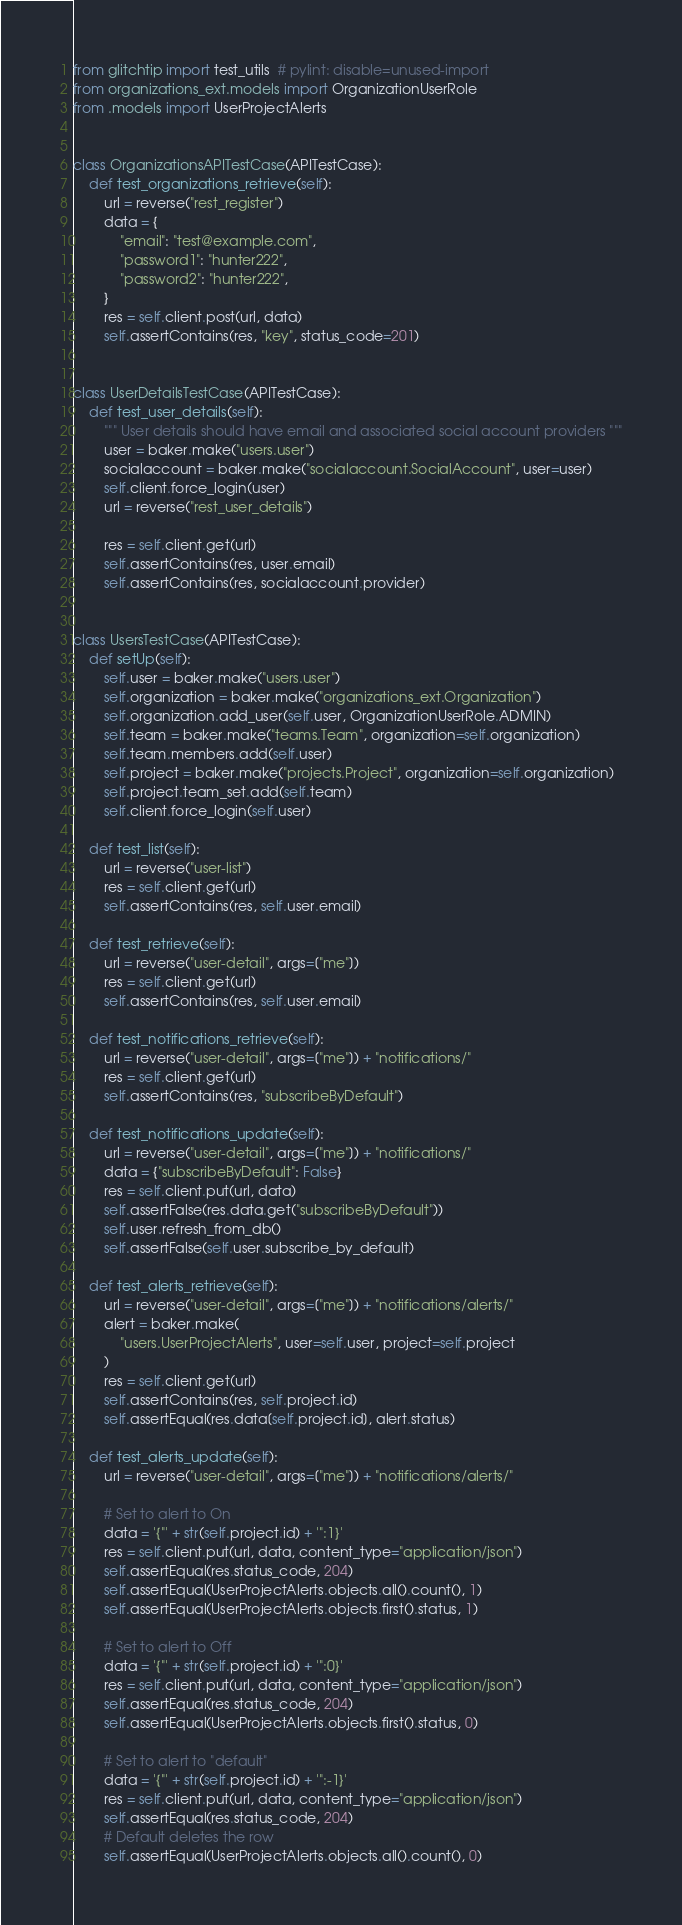<code> <loc_0><loc_0><loc_500><loc_500><_Python_>from glitchtip import test_utils  # pylint: disable=unused-import
from organizations_ext.models import OrganizationUserRole
from .models import UserProjectAlerts


class OrganizationsAPITestCase(APITestCase):
    def test_organizations_retrieve(self):
        url = reverse("rest_register")
        data = {
            "email": "test@example.com",
            "password1": "hunter222",
            "password2": "hunter222",
        }
        res = self.client.post(url, data)
        self.assertContains(res, "key", status_code=201)


class UserDetailsTestCase(APITestCase):
    def test_user_details(self):
        """ User details should have email and associated social account providers """
        user = baker.make("users.user")
        socialaccount = baker.make("socialaccount.SocialAccount", user=user)
        self.client.force_login(user)
        url = reverse("rest_user_details")

        res = self.client.get(url)
        self.assertContains(res, user.email)
        self.assertContains(res, socialaccount.provider)


class UsersTestCase(APITestCase):
    def setUp(self):
        self.user = baker.make("users.user")
        self.organization = baker.make("organizations_ext.Organization")
        self.organization.add_user(self.user, OrganizationUserRole.ADMIN)
        self.team = baker.make("teams.Team", organization=self.organization)
        self.team.members.add(self.user)
        self.project = baker.make("projects.Project", organization=self.organization)
        self.project.team_set.add(self.team)
        self.client.force_login(self.user)

    def test_list(self):
        url = reverse("user-list")
        res = self.client.get(url)
        self.assertContains(res, self.user.email)

    def test_retrieve(self):
        url = reverse("user-detail", args=["me"])
        res = self.client.get(url)
        self.assertContains(res, self.user.email)

    def test_notifications_retrieve(self):
        url = reverse("user-detail", args=["me"]) + "notifications/"
        res = self.client.get(url)
        self.assertContains(res, "subscribeByDefault")

    def test_notifications_update(self):
        url = reverse("user-detail", args=["me"]) + "notifications/"
        data = {"subscribeByDefault": False}
        res = self.client.put(url, data)
        self.assertFalse(res.data.get("subscribeByDefault"))
        self.user.refresh_from_db()
        self.assertFalse(self.user.subscribe_by_default)

    def test_alerts_retrieve(self):
        url = reverse("user-detail", args=["me"]) + "notifications/alerts/"
        alert = baker.make(
            "users.UserProjectAlerts", user=self.user, project=self.project
        )
        res = self.client.get(url)
        self.assertContains(res, self.project.id)
        self.assertEqual(res.data[self.project.id], alert.status)

    def test_alerts_update(self):
        url = reverse("user-detail", args=["me"]) + "notifications/alerts/"

        # Set to alert to On
        data = '{"' + str(self.project.id) + '":1}'
        res = self.client.put(url, data, content_type="application/json")
        self.assertEqual(res.status_code, 204)
        self.assertEqual(UserProjectAlerts.objects.all().count(), 1)
        self.assertEqual(UserProjectAlerts.objects.first().status, 1)

        # Set to alert to Off
        data = '{"' + str(self.project.id) + '":0}'
        res = self.client.put(url, data, content_type="application/json")
        self.assertEqual(res.status_code, 204)
        self.assertEqual(UserProjectAlerts.objects.first().status, 0)

        # Set to alert to "default"
        data = '{"' + str(self.project.id) + '":-1}'
        res = self.client.put(url, data, content_type="application/json")
        self.assertEqual(res.status_code, 204)
        # Default deletes the row
        self.assertEqual(UserProjectAlerts.objects.all().count(), 0)
</code> 